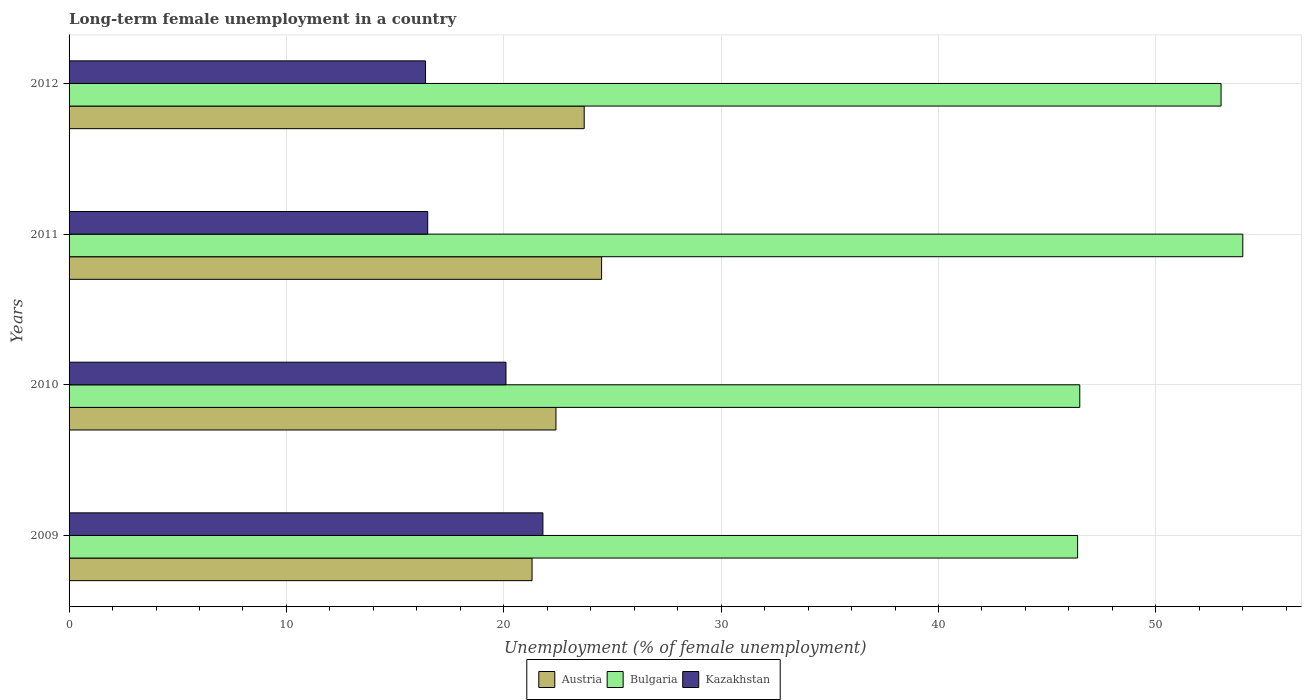How many groups of bars are there?
Give a very brief answer. 4. Are the number of bars on each tick of the Y-axis equal?
Your answer should be compact. Yes. How many bars are there on the 2nd tick from the top?
Give a very brief answer. 3. What is the percentage of long-term unemployed female population in Austria in 2011?
Give a very brief answer. 24.5. Across all years, what is the maximum percentage of long-term unemployed female population in Bulgaria?
Keep it short and to the point. 54. Across all years, what is the minimum percentage of long-term unemployed female population in Austria?
Give a very brief answer. 21.3. In which year was the percentage of long-term unemployed female population in Austria maximum?
Your answer should be very brief. 2011. In which year was the percentage of long-term unemployed female population in Austria minimum?
Provide a short and direct response. 2009. What is the total percentage of long-term unemployed female population in Bulgaria in the graph?
Your answer should be compact. 199.9. What is the difference between the percentage of long-term unemployed female population in Bulgaria in 2010 and that in 2011?
Offer a terse response. -7.5. What is the difference between the percentage of long-term unemployed female population in Bulgaria in 2010 and the percentage of long-term unemployed female population in Kazakhstan in 2009?
Offer a very short reply. 24.7. What is the average percentage of long-term unemployed female population in Kazakhstan per year?
Provide a short and direct response. 18.7. In the year 2011, what is the difference between the percentage of long-term unemployed female population in Bulgaria and percentage of long-term unemployed female population in Austria?
Provide a short and direct response. 29.5. In how many years, is the percentage of long-term unemployed female population in Bulgaria greater than 38 %?
Provide a succinct answer. 4. What is the ratio of the percentage of long-term unemployed female population in Bulgaria in 2009 to that in 2012?
Keep it short and to the point. 0.88. What is the difference between the highest and the second highest percentage of long-term unemployed female population in Bulgaria?
Keep it short and to the point. 1. What is the difference between the highest and the lowest percentage of long-term unemployed female population in Kazakhstan?
Provide a short and direct response. 5.4. What does the 3rd bar from the top in 2010 represents?
Give a very brief answer. Austria. Is it the case that in every year, the sum of the percentage of long-term unemployed female population in Kazakhstan and percentage of long-term unemployed female population in Austria is greater than the percentage of long-term unemployed female population in Bulgaria?
Your answer should be compact. No. What is the difference between two consecutive major ticks on the X-axis?
Ensure brevity in your answer.  10. Are the values on the major ticks of X-axis written in scientific E-notation?
Provide a succinct answer. No. Does the graph contain any zero values?
Offer a very short reply. No. Where does the legend appear in the graph?
Make the answer very short. Bottom center. How are the legend labels stacked?
Provide a short and direct response. Horizontal. What is the title of the graph?
Your answer should be compact. Long-term female unemployment in a country. Does "Mauritius" appear as one of the legend labels in the graph?
Offer a terse response. No. What is the label or title of the X-axis?
Provide a succinct answer. Unemployment (% of female unemployment). What is the label or title of the Y-axis?
Keep it short and to the point. Years. What is the Unemployment (% of female unemployment) of Austria in 2009?
Offer a very short reply. 21.3. What is the Unemployment (% of female unemployment) of Bulgaria in 2009?
Offer a terse response. 46.4. What is the Unemployment (% of female unemployment) in Kazakhstan in 2009?
Make the answer very short. 21.8. What is the Unemployment (% of female unemployment) in Austria in 2010?
Your answer should be very brief. 22.4. What is the Unemployment (% of female unemployment) in Bulgaria in 2010?
Your answer should be compact. 46.5. What is the Unemployment (% of female unemployment) of Kazakhstan in 2010?
Your answer should be compact. 20.1. What is the Unemployment (% of female unemployment) of Austria in 2011?
Offer a very short reply. 24.5. What is the Unemployment (% of female unemployment) of Austria in 2012?
Provide a succinct answer. 23.7. What is the Unemployment (% of female unemployment) in Kazakhstan in 2012?
Your response must be concise. 16.4. Across all years, what is the maximum Unemployment (% of female unemployment) in Austria?
Provide a short and direct response. 24.5. Across all years, what is the maximum Unemployment (% of female unemployment) of Kazakhstan?
Your answer should be very brief. 21.8. Across all years, what is the minimum Unemployment (% of female unemployment) in Austria?
Your response must be concise. 21.3. Across all years, what is the minimum Unemployment (% of female unemployment) in Bulgaria?
Your answer should be very brief. 46.4. Across all years, what is the minimum Unemployment (% of female unemployment) of Kazakhstan?
Offer a very short reply. 16.4. What is the total Unemployment (% of female unemployment) of Austria in the graph?
Make the answer very short. 91.9. What is the total Unemployment (% of female unemployment) of Bulgaria in the graph?
Offer a very short reply. 199.9. What is the total Unemployment (% of female unemployment) in Kazakhstan in the graph?
Give a very brief answer. 74.8. What is the difference between the Unemployment (% of female unemployment) in Kazakhstan in 2009 and that in 2010?
Your answer should be compact. 1.7. What is the difference between the Unemployment (% of female unemployment) in Kazakhstan in 2009 and that in 2011?
Offer a very short reply. 5.3. What is the difference between the Unemployment (% of female unemployment) in Austria in 2009 and that in 2012?
Your answer should be very brief. -2.4. What is the difference between the Unemployment (% of female unemployment) of Austria in 2010 and that in 2011?
Your answer should be compact. -2.1. What is the difference between the Unemployment (% of female unemployment) of Bulgaria in 2010 and that in 2011?
Offer a very short reply. -7.5. What is the difference between the Unemployment (% of female unemployment) of Kazakhstan in 2010 and that in 2011?
Provide a succinct answer. 3.6. What is the difference between the Unemployment (% of female unemployment) of Austria in 2010 and that in 2012?
Ensure brevity in your answer.  -1.3. What is the difference between the Unemployment (% of female unemployment) in Bulgaria in 2010 and that in 2012?
Make the answer very short. -6.5. What is the difference between the Unemployment (% of female unemployment) in Kazakhstan in 2010 and that in 2012?
Keep it short and to the point. 3.7. What is the difference between the Unemployment (% of female unemployment) of Austria in 2011 and that in 2012?
Make the answer very short. 0.8. What is the difference between the Unemployment (% of female unemployment) of Bulgaria in 2011 and that in 2012?
Ensure brevity in your answer.  1. What is the difference between the Unemployment (% of female unemployment) in Austria in 2009 and the Unemployment (% of female unemployment) in Bulgaria in 2010?
Offer a very short reply. -25.2. What is the difference between the Unemployment (% of female unemployment) in Austria in 2009 and the Unemployment (% of female unemployment) in Kazakhstan in 2010?
Provide a short and direct response. 1.2. What is the difference between the Unemployment (% of female unemployment) in Bulgaria in 2009 and the Unemployment (% of female unemployment) in Kazakhstan in 2010?
Provide a succinct answer. 26.3. What is the difference between the Unemployment (% of female unemployment) of Austria in 2009 and the Unemployment (% of female unemployment) of Bulgaria in 2011?
Ensure brevity in your answer.  -32.7. What is the difference between the Unemployment (% of female unemployment) of Bulgaria in 2009 and the Unemployment (% of female unemployment) of Kazakhstan in 2011?
Give a very brief answer. 29.9. What is the difference between the Unemployment (% of female unemployment) in Austria in 2009 and the Unemployment (% of female unemployment) in Bulgaria in 2012?
Ensure brevity in your answer.  -31.7. What is the difference between the Unemployment (% of female unemployment) in Austria in 2010 and the Unemployment (% of female unemployment) in Bulgaria in 2011?
Make the answer very short. -31.6. What is the difference between the Unemployment (% of female unemployment) of Austria in 2010 and the Unemployment (% of female unemployment) of Kazakhstan in 2011?
Provide a succinct answer. 5.9. What is the difference between the Unemployment (% of female unemployment) in Bulgaria in 2010 and the Unemployment (% of female unemployment) in Kazakhstan in 2011?
Your response must be concise. 30. What is the difference between the Unemployment (% of female unemployment) in Austria in 2010 and the Unemployment (% of female unemployment) in Bulgaria in 2012?
Your answer should be compact. -30.6. What is the difference between the Unemployment (% of female unemployment) in Bulgaria in 2010 and the Unemployment (% of female unemployment) in Kazakhstan in 2012?
Provide a succinct answer. 30.1. What is the difference between the Unemployment (% of female unemployment) of Austria in 2011 and the Unemployment (% of female unemployment) of Bulgaria in 2012?
Provide a succinct answer. -28.5. What is the difference between the Unemployment (% of female unemployment) of Austria in 2011 and the Unemployment (% of female unemployment) of Kazakhstan in 2012?
Offer a terse response. 8.1. What is the difference between the Unemployment (% of female unemployment) in Bulgaria in 2011 and the Unemployment (% of female unemployment) in Kazakhstan in 2012?
Give a very brief answer. 37.6. What is the average Unemployment (% of female unemployment) of Austria per year?
Your answer should be very brief. 22.98. What is the average Unemployment (% of female unemployment) of Bulgaria per year?
Make the answer very short. 49.98. In the year 2009, what is the difference between the Unemployment (% of female unemployment) of Austria and Unemployment (% of female unemployment) of Bulgaria?
Provide a succinct answer. -25.1. In the year 2009, what is the difference between the Unemployment (% of female unemployment) of Bulgaria and Unemployment (% of female unemployment) of Kazakhstan?
Keep it short and to the point. 24.6. In the year 2010, what is the difference between the Unemployment (% of female unemployment) of Austria and Unemployment (% of female unemployment) of Bulgaria?
Provide a short and direct response. -24.1. In the year 2010, what is the difference between the Unemployment (% of female unemployment) in Bulgaria and Unemployment (% of female unemployment) in Kazakhstan?
Make the answer very short. 26.4. In the year 2011, what is the difference between the Unemployment (% of female unemployment) of Austria and Unemployment (% of female unemployment) of Bulgaria?
Your answer should be compact. -29.5. In the year 2011, what is the difference between the Unemployment (% of female unemployment) in Bulgaria and Unemployment (% of female unemployment) in Kazakhstan?
Give a very brief answer. 37.5. In the year 2012, what is the difference between the Unemployment (% of female unemployment) of Austria and Unemployment (% of female unemployment) of Bulgaria?
Your answer should be compact. -29.3. In the year 2012, what is the difference between the Unemployment (% of female unemployment) in Austria and Unemployment (% of female unemployment) in Kazakhstan?
Your answer should be compact. 7.3. In the year 2012, what is the difference between the Unemployment (% of female unemployment) of Bulgaria and Unemployment (% of female unemployment) of Kazakhstan?
Offer a terse response. 36.6. What is the ratio of the Unemployment (% of female unemployment) in Austria in 2009 to that in 2010?
Keep it short and to the point. 0.95. What is the ratio of the Unemployment (% of female unemployment) of Kazakhstan in 2009 to that in 2010?
Your answer should be compact. 1.08. What is the ratio of the Unemployment (% of female unemployment) in Austria in 2009 to that in 2011?
Make the answer very short. 0.87. What is the ratio of the Unemployment (% of female unemployment) in Bulgaria in 2009 to that in 2011?
Make the answer very short. 0.86. What is the ratio of the Unemployment (% of female unemployment) of Kazakhstan in 2009 to that in 2011?
Make the answer very short. 1.32. What is the ratio of the Unemployment (% of female unemployment) in Austria in 2009 to that in 2012?
Offer a very short reply. 0.9. What is the ratio of the Unemployment (% of female unemployment) in Bulgaria in 2009 to that in 2012?
Provide a succinct answer. 0.88. What is the ratio of the Unemployment (% of female unemployment) in Kazakhstan in 2009 to that in 2012?
Your answer should be compact. 1.33. What is the ratio of the Unemployment (% of female unemployment) of Austria in 2010 to that in 2011?
Provide a short and direct response. 0.91. What is the ratio of the Unemployment (% of female unemployment) of Bulgaria in 2010 to that in 2011?
Offer a very short reply. 0.86. What is the ratio of the Unemployment (% of female unemployment) in Kazakhstan in 2010 to that in 2011?
Your answer should be very brief. 1.22. What is the ratio of the Unemployment (% of female unemployment) in Austria in 2010 to that in 2012?
Make the answer very short. 0.95. What is the ratio of the Unemployment (% of female unemployment) in Bulgaria in 2010 to that in 2012?
Make the answer very short. 0.88. What is the ratio of the Unemployment (% of female unemployment) in Kazakhstan in 2010 to that in 2012?
Offer a terse response. 1.23. What is the ratio of the Unemployment (% of female unemployment) of Austria in 2011 to that in 2012?
Your answer should be very brief. 1.03. What is the ratio of the Unemployment (% of female unemployment) in Bulgaria in 2011 to that in 2012?
Provide a succinct answer. 1.02. What is the difference between the highest and the second highest Unemployment (% of female unemployment) in Austria?
Ensure brevity in your answer.  0.8. What is the difference between the highest and the second highest Unemployment (% of female unemployment) in Kazakhstan?
Your response must be concise. 1.7. What is the difference between the highest and the lowest Unemployment (% of female unemployment) in Bulgaria?
Provide a succinct answer. 7.6. What is the difference between the highest and the lowest Unemployment (% of female unemployment) in Kazakhstan?
Provide a succinct answer. 5.4. 